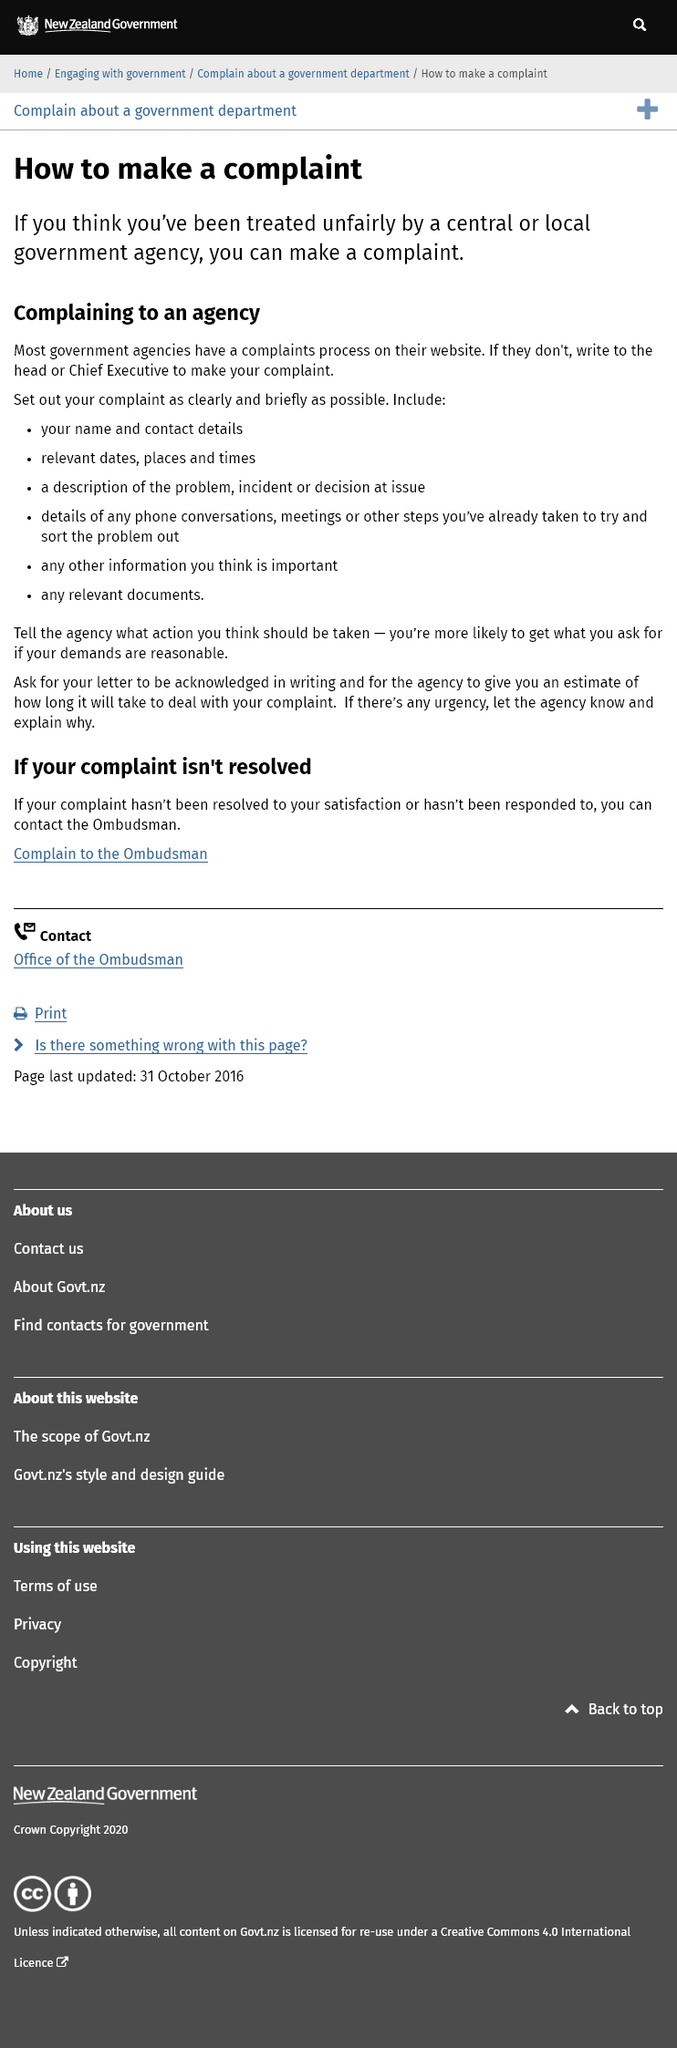Mention a couple of crucial points in this snapshot. You asked for an estimate of how long it will take to deal with your complaint, and we have provided it to you in our letter. If there is an urgency to the matter, please notify the agency and provide a reason for the urgency. To file a complaint against a local agency, a letter should be written to the head or Chief Executive, outlining the issue clearly and concisely. 